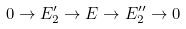<formula> <loc_0><loc_0><loc_500><loc_500>0 \to E _ { 2 } ^ { \prime } \to E \to E _ { 2 } ^ { \prime \prime } \to 0</formula> 